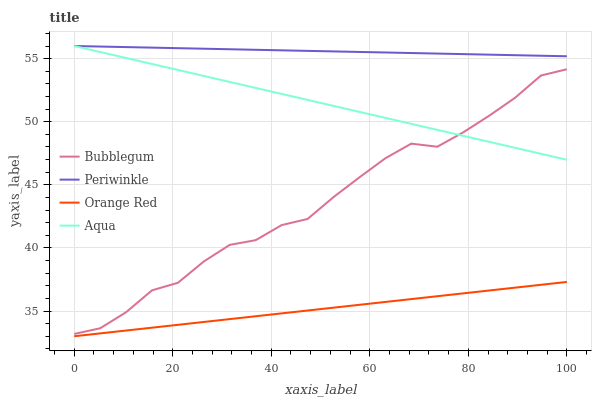Does Orange Red have the minimum area under the curve?
Answer yes or no. Yes. Does Periwinkle have the maximum area under the curve?
Answer yes or no. Yes. Does Periwinkle have the minimum area under the curve?
Answer yes or no. No. Does Orange Red have the maximum area under the curve?
Answer yes or no. No. Is Periwinkle the smoothest?
Answer yes or no. Yes. Is Bubblegum the roughest?
Answer yes or no. Yes. Is Orange Red the smoothest?
Answer yes or no. No. Is Orange Red the roughest?
Answer yes or no. No. Does Orange Red have the lowest value?
Answer yes or no. Yes. Does Periwinkle have the lowest value?
Answer yes or no. No. Does Periwinkle have the highest value?
Answer yes or no. Yes. Does Orange Red have the highest value?
Answer yes or no. No. Is Orange Red less than Bubblegum?
Answer yes or no. Yes. Is Periwinkle greater than Orange Red?
Answer yes or no. Yes. Does Bubblegum intersect Aqua?
Answer yes or no. Yes. Is Bubblegum less than Aqua?
Answer yes or no. No. Is Bubblegum greater than Aqua?
Answer yes or no. No. Does Orange Red intersect Bubblegum?
Answer yes or no. No. 